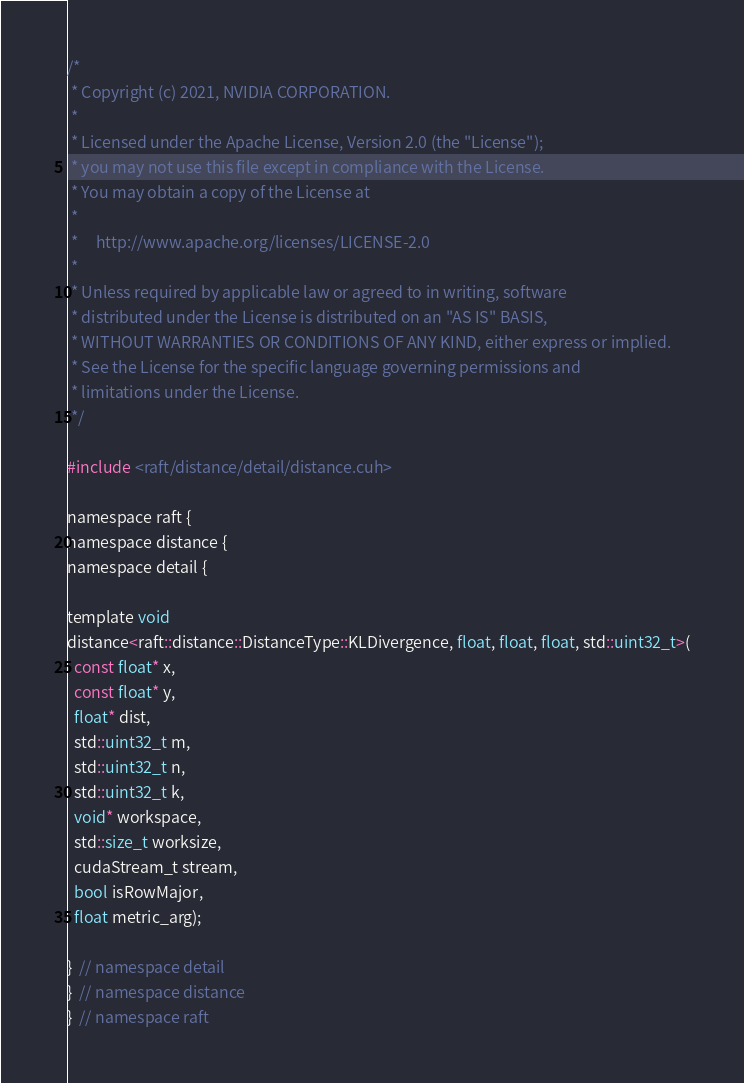Convert code to text. <code><loc_0><loc_0><loc_500><loc_500><_Cuda_>/*
 * Copyright (c) 2021, NVIDIA CORPORATION.
 *
 * Licensed under the Apache License, Version 2.0 (the "License");
 * you may not use this file except in compliance with the License.
 * You may obtain a copy of the License at
 *
 *     http://www.apache.org/licenses/LICENSE-2.0
 *
 * Unless required by applicable law or agreed to in writing, software
 * distributed under the License is distributed on an "AS IS" BASIS,
 * WITHOUT WARRANTIES OR CONDITIONS OF ANY KIND, either express or implied.
 * See the License for the specific language governing permissions and
 * limitations under the License.
 */

#include <raft/distance/detail/distance.cuh>

namespace raft {
namespace distance {
namespace detail {

template void
distance<raft::distance::DistanceType::KLDivergence, float, float, float, std::uint32_t>(
  const float* x,
  const float* y,
  float* dist,
  std::uint32_t m,
  std::uint32_t n,
  std::uint32_t k,
  void* workspace,
  std::size_t worksize,
  cudaStream_t stream,
  bool isRowMajor,
  float metric_arg);

}  // namespace detail
}  // namespace distance
}  // namespace raft
</code> 